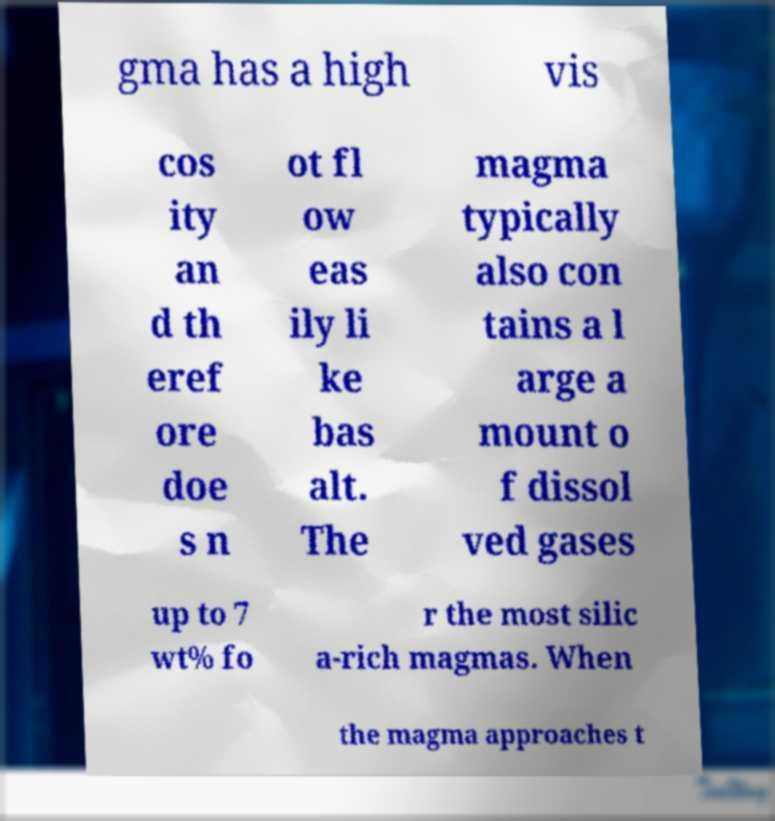Could you assist in decoding the text presented in this image and type it out clearly? gma has a high vis cos ity an d th eref ore doe s n ot fl ow eas ily li ke bas alt. The magma typically also con tains a l arge a mount o f dissol ved gases up to 7 wt% fo r the most silic a-rich magmas. When the magma approaches t 